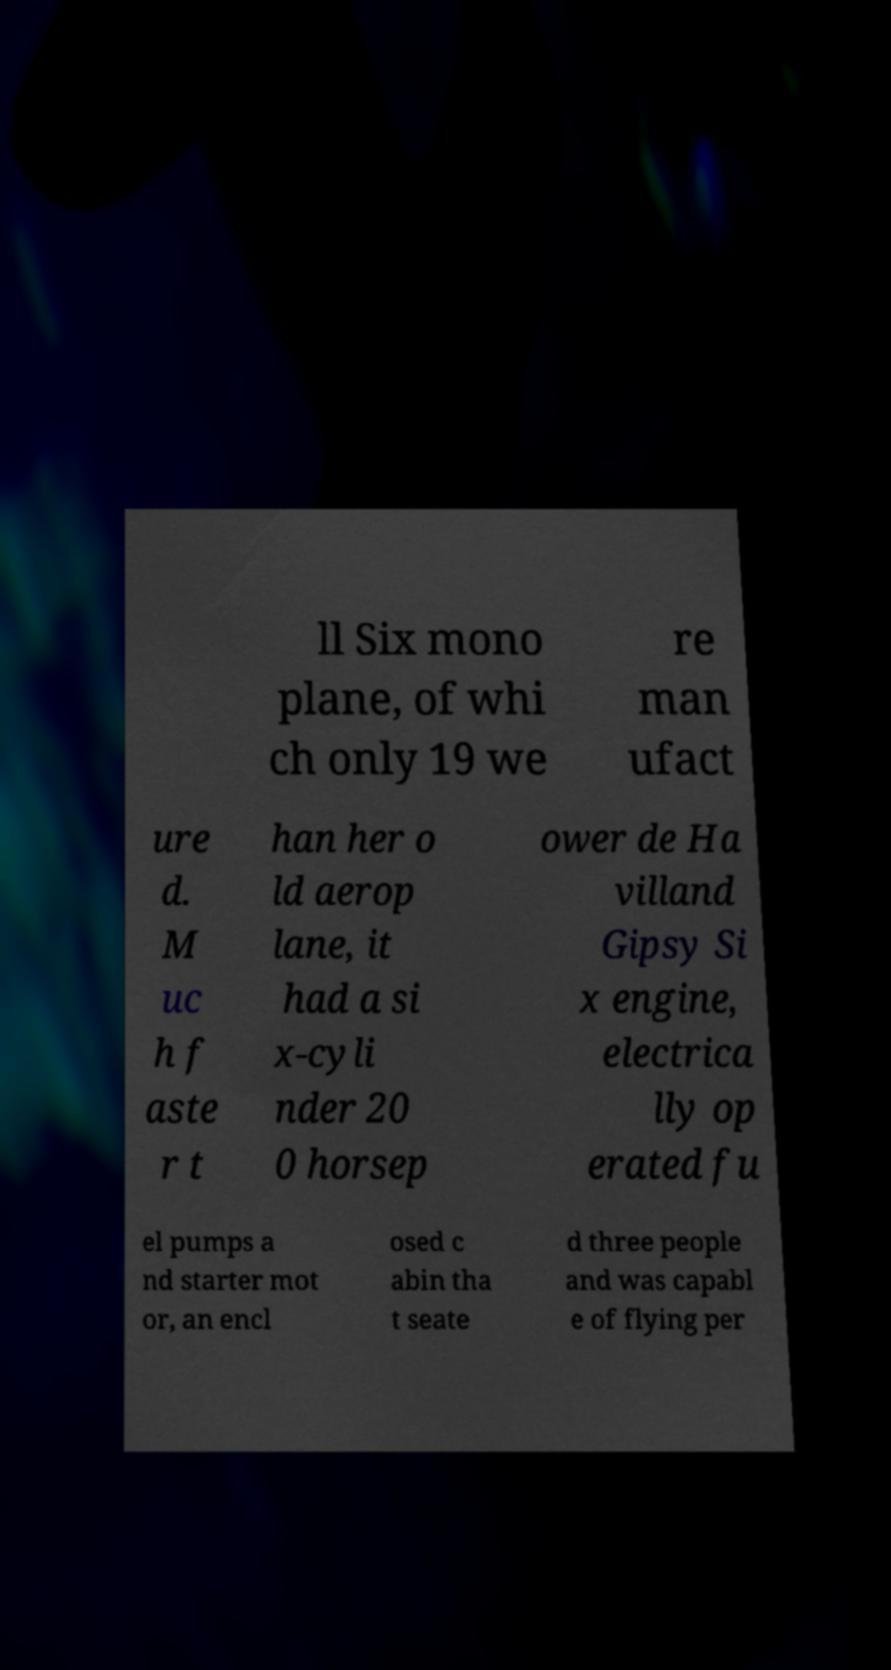For documentation purposes, I need the text within this image transcribed. Could you provide that? ll Six mono plane, of whi ch only 19 we re man ufact ure d. M uc h f aste r t han her o ld aerop lane, it had a si x-cyli nder 20 0 horsep ower de Ha villand Gipsy Si x engine, electrica lly op erated fu el pumps a nd starter mot or, an encl osed c abin tha t seate d three people and was capabl e of flying per 